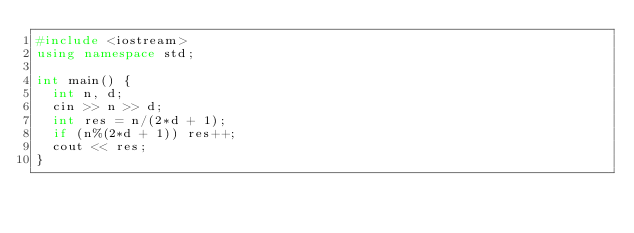Convert code to text. <code><loc_0><loc_0><loc_500><loc_500><_C++_>#include <iostream>
using namespace std;

int main() {
	int n, d;
	cin >> n >> d;
	int res = n/(2*d + 1);
	if (n%(2*d + 1)) res++;
	cout << res;
}</code> 